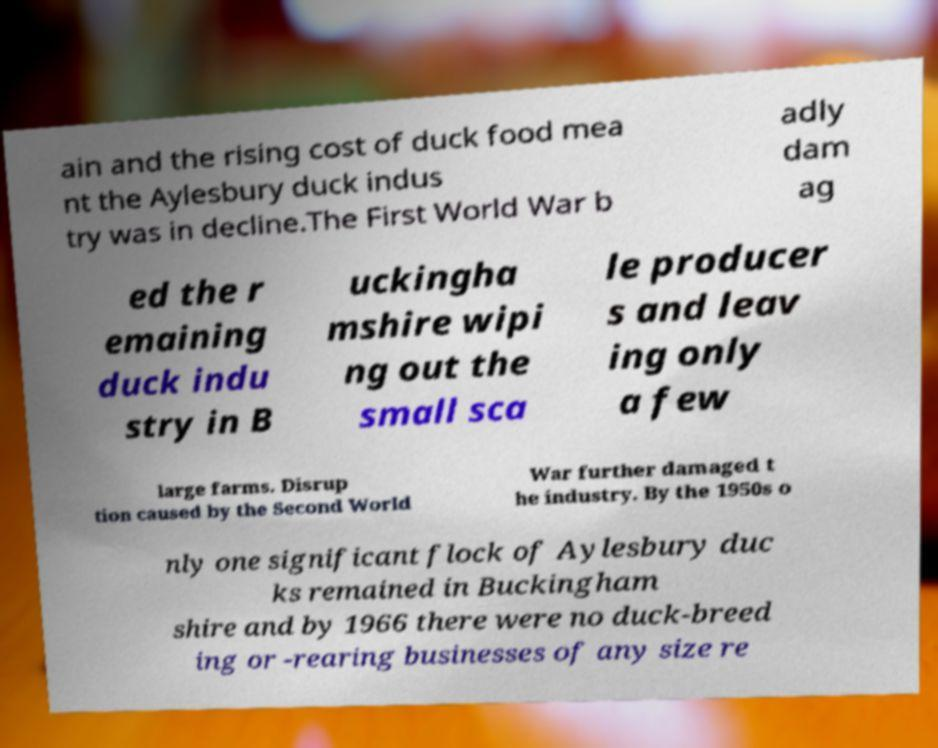I need the written content from this picture converted into text. Can you do that? ain and the rising cost of duck food mea nt the Aylesbury duck indus try was in decline.The First World War b adly dam ag ed the r emaining duck indu stry in B uckingha mshire wipi ng out the small sca le producer s and leav ing only a few large farms. Disrup tion caused by the Second World War further damaged t he industry. By the 1950s o nly one significant flock of Aylesbury duc ks remained in Buckingham shire and by 1966 there were no duck-breed ing or -rearing businesses of any size re 